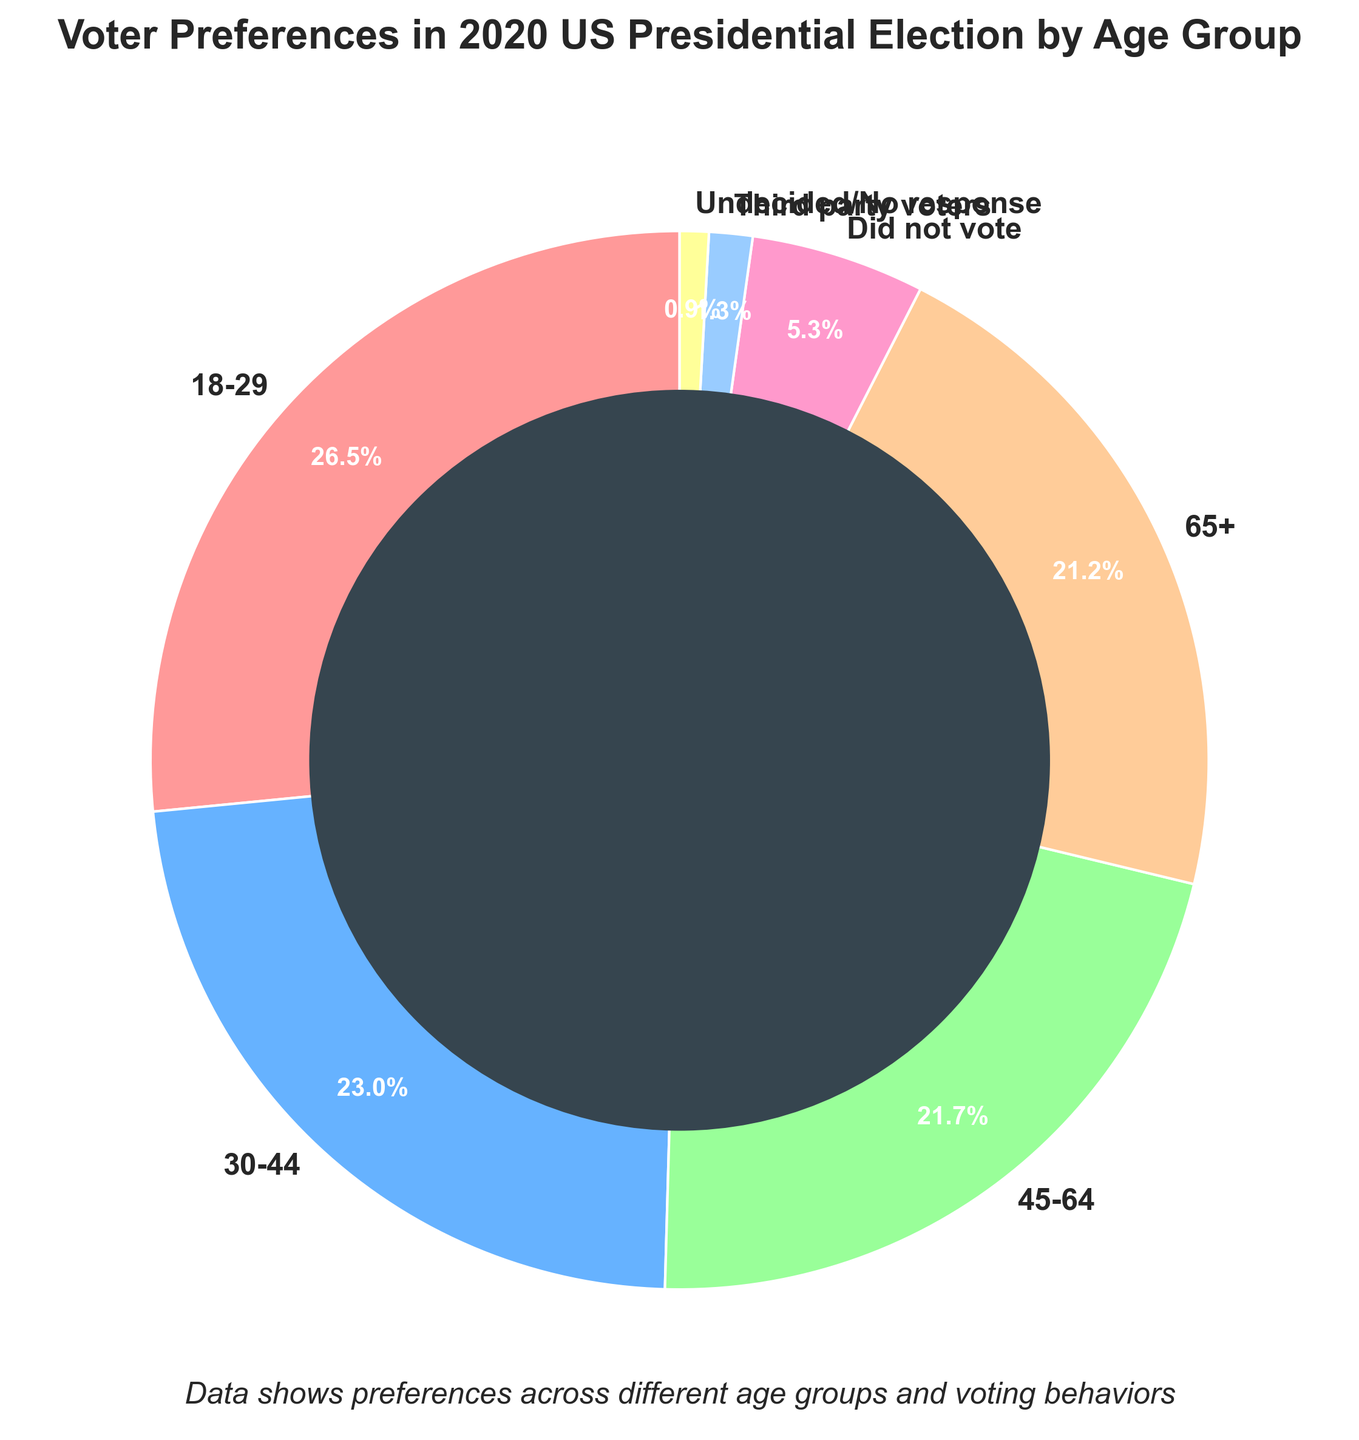Which age group has the highest voter preference in the 2020 US presidential election? The slice labeled "18-29" is the largest, indicating the highest voter preference.
Answer: 18-29 Compare the voter preferences between the age groups 45-64 and 65+. Which group is higher? The "45-64" group has a percentage of 49%, while the "65+" group has a percentage of 48%. Comparing these, the "45-64" group is higher.
Answer: 45-64 What percentage of voters did not vote? The slice labeled "Did not vote" shows a percentage of 12%.
Answer: 12% How many total percentage points do the "Third party voters" and "Undecided/No response" groups account for together? The "Third party voters" are 3% and "Undecided/No response" are 2%. Adding them together: 3 + 2 = 5
Answer: 5 Which age group has the lowest voter preference? The slice labeled "65+" is the smallest among the age groups, indicating the lowest voter preference.
Answer: 65+ Which age groups have a voter preference greater than 50%? The "18-29" group has 60% and the "30-44" group has 52%, both greater than 50%.
Answer: 18-29, 30-44 Is the percentage of voters aged 18-29 greater than the sum of "Did not vote" and "Undecided/No response"? The "18-29" group has 60%. The sum of "Did not vote" (12%) and "Undecided/No response" (2%) is 14%. Since 60% is greater than 14%, the answer is yes.
Answer: Yes Compare the visual length of the colored slices representing age group 18-29 and 45-64. Which one is visually longer? The slice for "18-29" is visually larger (longer) than the "45-64" slice, signifying a higher percentage.
Answer: 18-29 